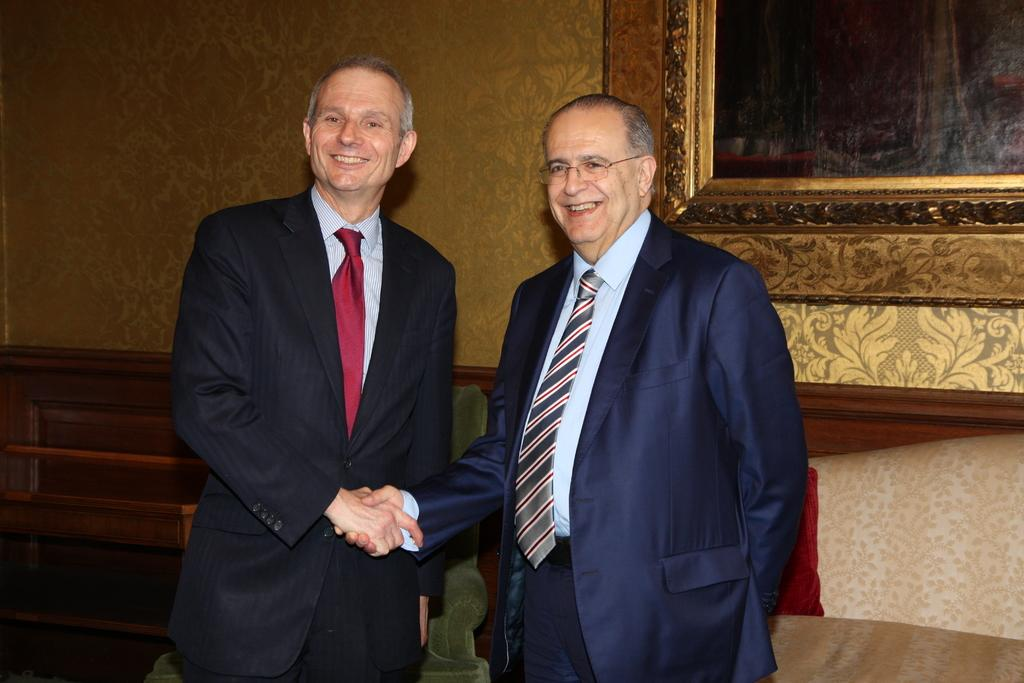How many people are in the image? There are two people standing in the image. What can be seen in the background of the image? There is a couch visible in the background. What material is present in the image? Wood is present in the image. What is attached to the wall in the image? There is a photo frame attached to the wall in the image. Is there any rain visible in the image? No, there is no rain visible in the image. What type of skin can be seen on the people in the image? The image does not show the skin of the people, so it cannot be determined from the image. 